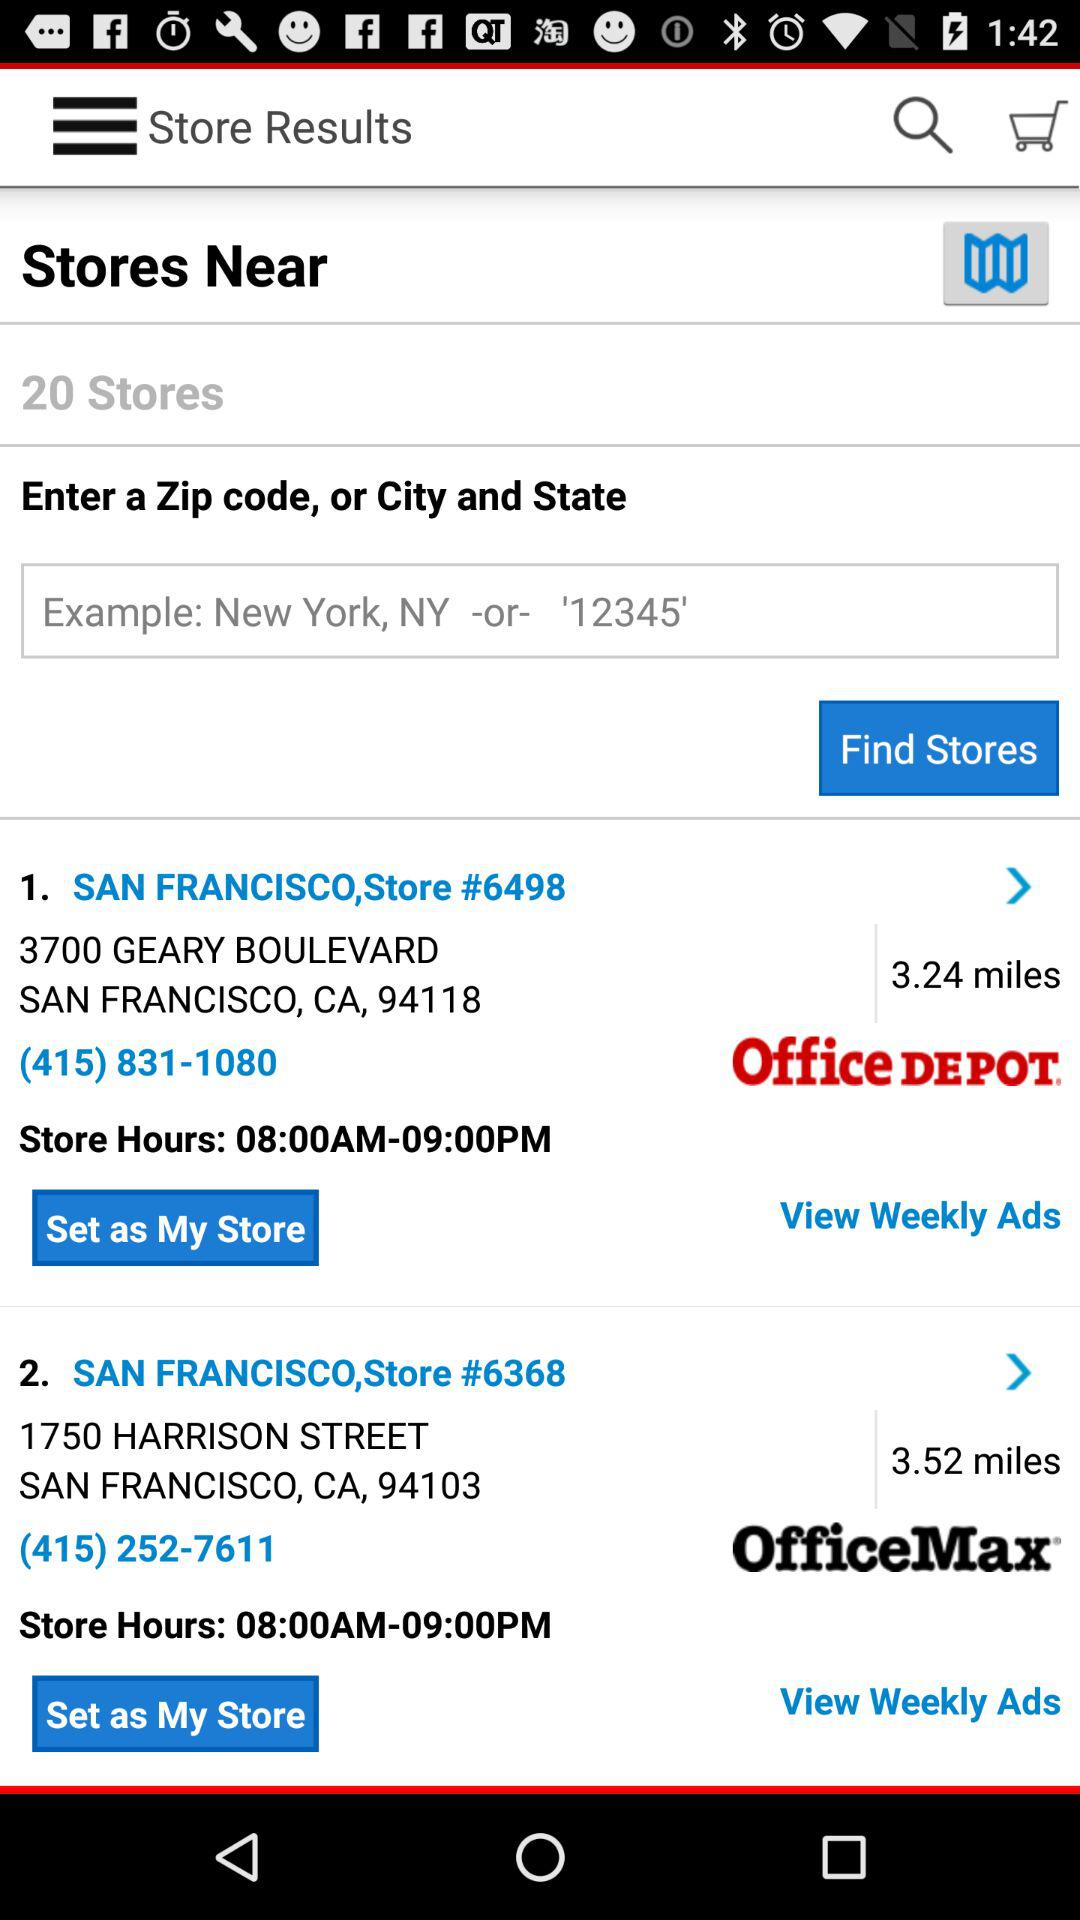What is the distance to the store number, 6498? The distance is 3.24 miles. 